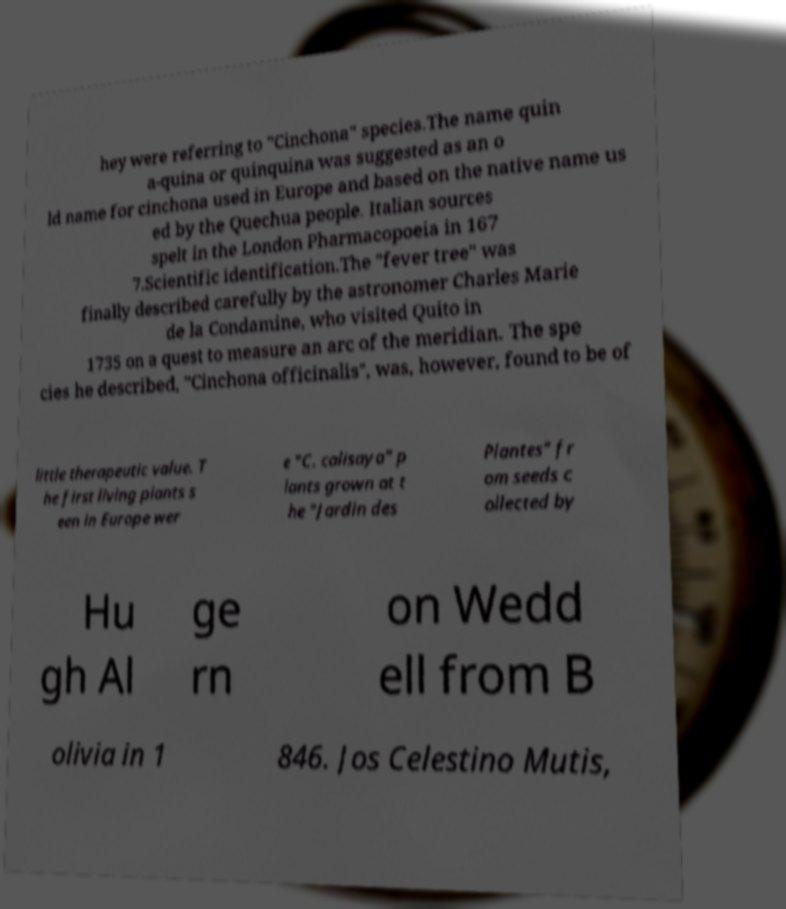What messages or text are displayed in this image? I need them in a readable, typed format. hey were referring to "Cinchona" species.The name quin a-quina or quinquina was suggested as an o ld name for cinchona used in Europe and based on the native name us ed by the Quechua people. Italian sources spelt in the London Pharmacopoeia in 167 7.Scientific identification.The "fever tree" was finally described carefully by the astronomer Charles Marie de la Condamine, who visited Quito in 1735 on a quest to measure an arc of the meridian. The spe cies he described, "Cinchona officinalis", was, however, found to be of little therapeutic value. T he first living plants s een in Europe wer e "C. calisaya" p lants grown at t he "Jardin des Plantes" fr om seeds c ollected by Hu gh Al ge rn on Wedd ell from B olivia in 1 846. Jos Celestino Mutis, 